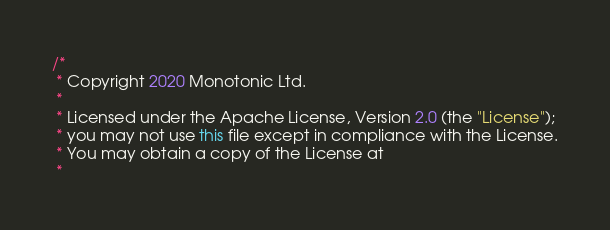Convert code to text. <code><loc_0><loc_0><loc_500><loc_500><_Java_>/*
 * Copyright 2020 Monotonic Ltd.
 *
 * Licensed under the Apache License, Version 2.0 (the "License");
 * you may not use this file except in compliance with the License.
 * You may obtain a copy of the License at
 *</code> 